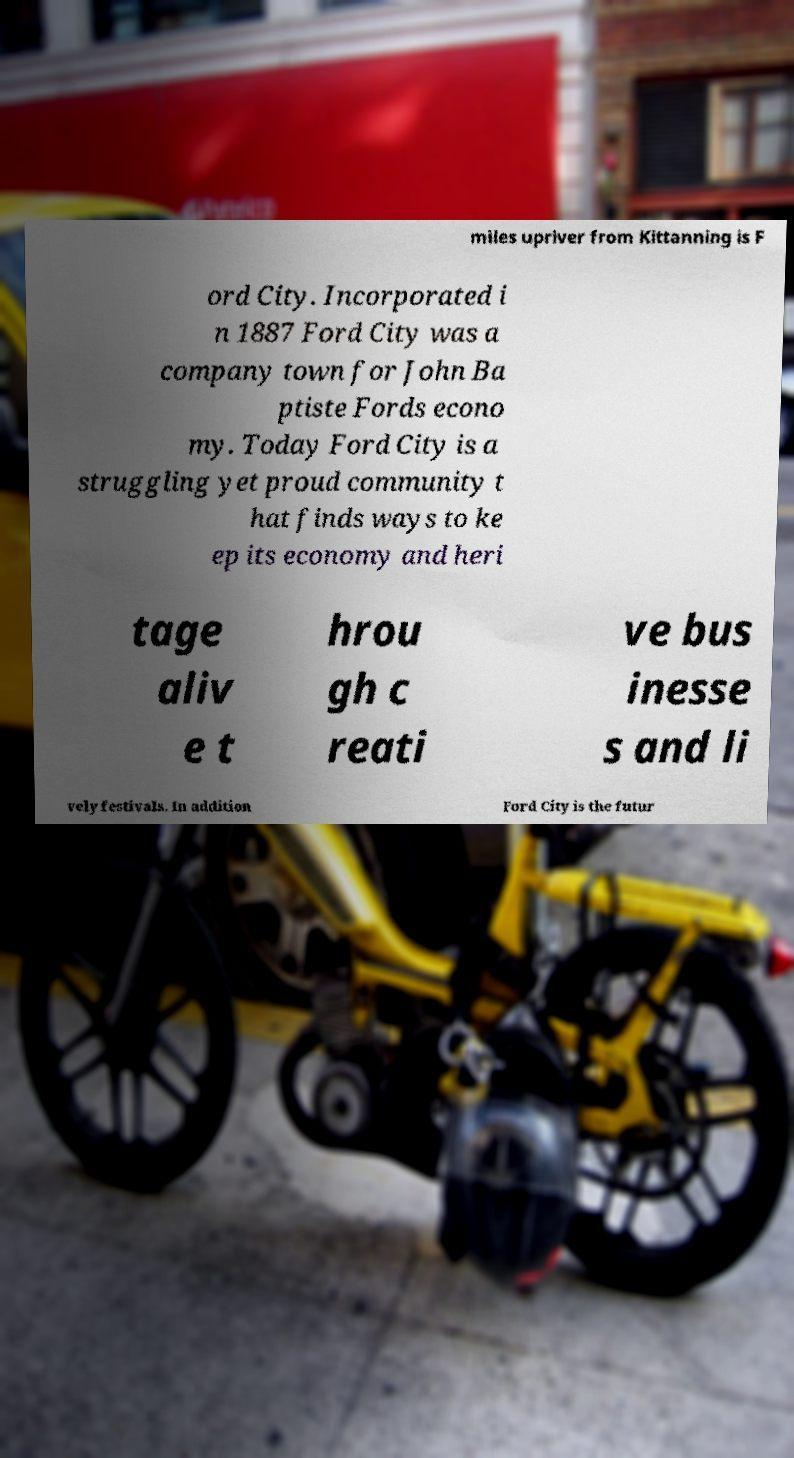Could you assist in decoding the text presented in this image and type it out clearly? miles upriver from Kittanning is F ord City. Incorporated i n 1887 Ford City was a company town for John Ba ptiste Fords econo my. Today Ford City is a struggling yet proud community t hat finds ways to ke ep its economy and heri tage aliv e t hrou gh c reati ve bus inesse s and li vely festivals. In addition Ford City is the futur 